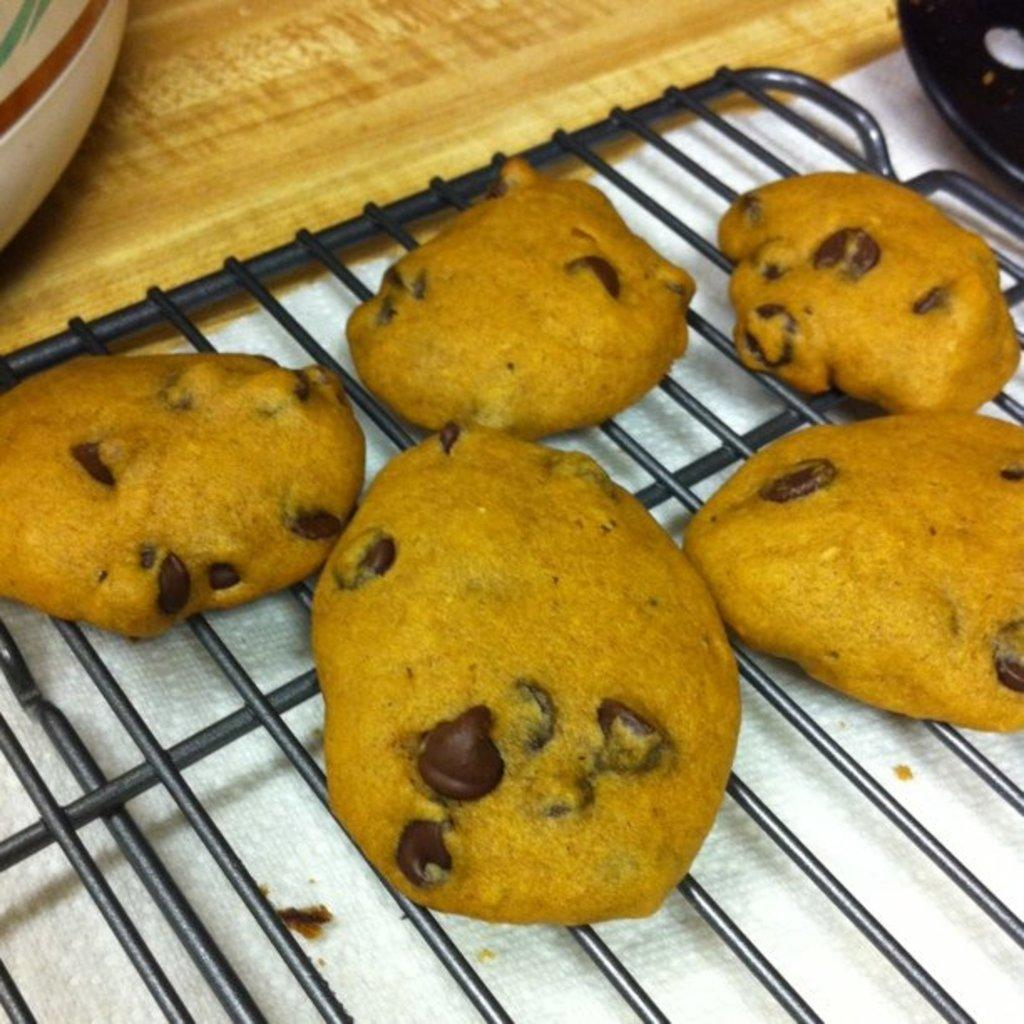What is the main subject of the image? The main subject of the image is food. What is the color of the grill on which the food is placed? The grill is black in color. What is the color of the food? The food is in yellow color. What is the color of the table on which the grill is placed? The table is cream color. Can you tell me how many teeth the dog has in the image? There is no dog present in the image, so it is not possible to determine the number of teeth it might have. 